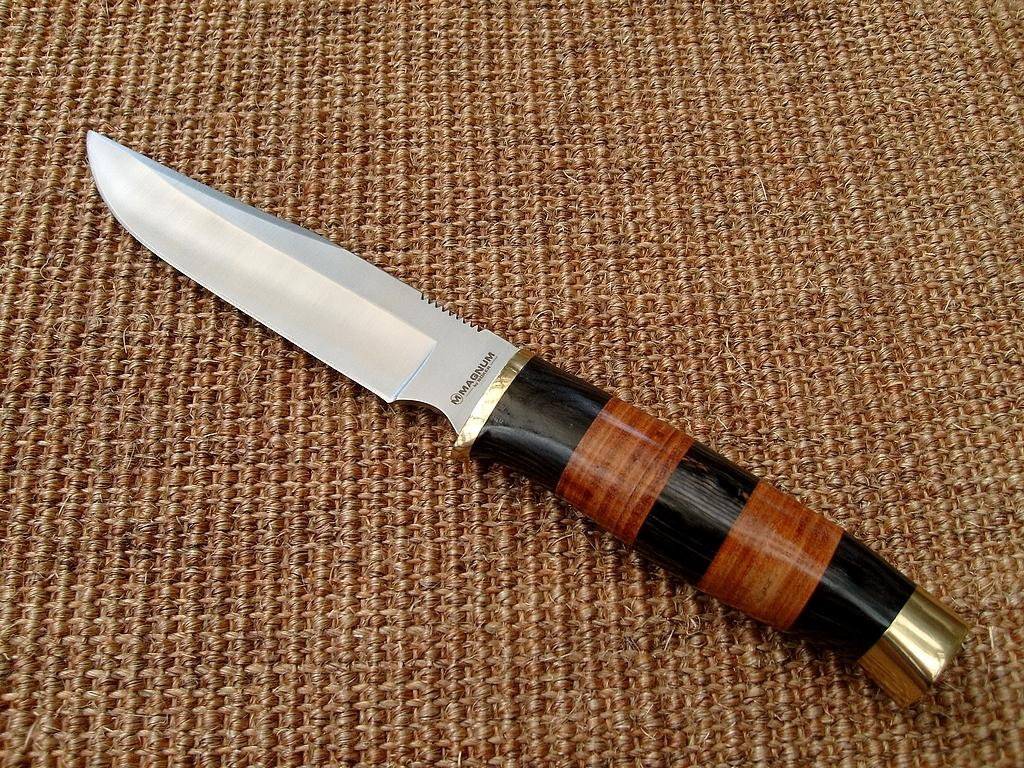What object is present in the image that can be used for cutting? There is a knife in the image. What is the color of the surface on which the knife is placed? The knife is on a brown color surface. What type of fruit is being sliced by the knife in the image? There is no fruit present in the image; only a knife on a brown color surface is visible. 